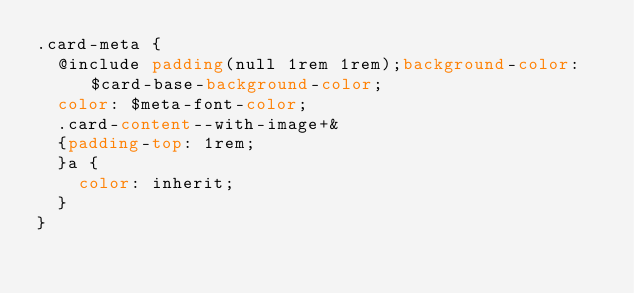<code> <loc_0><loc_0><loc_500><loc_500><_CSS_>.card-meta {
  @include padding(null 1rem 1rem);background-color: $card-base-background-color;
  color: $meta-font-color;
  .card-content--with-image+&
  {padding-top: 1rem;
  }a {
    color: inherit;
  }
}
</code> 